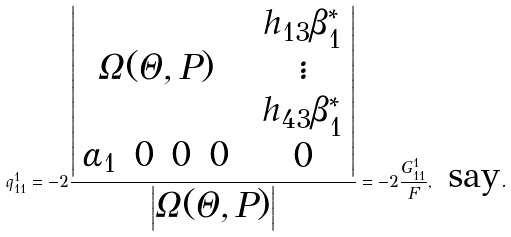Convert formula to latex. <formula><loc_0><loc_0><loc_500><loc_500>q _ { 1 1 } ^ { 1 } = - 2 \frac { \begin{vmatrix} \Omega ( \Theta , P ) & \begin{array} { c } h _ { 1 3 } \beta _ { 1 } ^ { * } \\ \vdots \\ h _ { 4 3 } \beta _ { 1 } ^ { * } \end{array} \\ \begin{array} { c c c c } \alpha _ { 1 } & 0 & 0 & 0 \end{array} & 0 \end{vmatrix} } { \begin{vmatrix} \Omega ( \Theta , P ) \end{vmatrix} } = - 2 \frac { G _ { 1 1 } ^ { 1 } } { F } , \text { say} .</formula> 